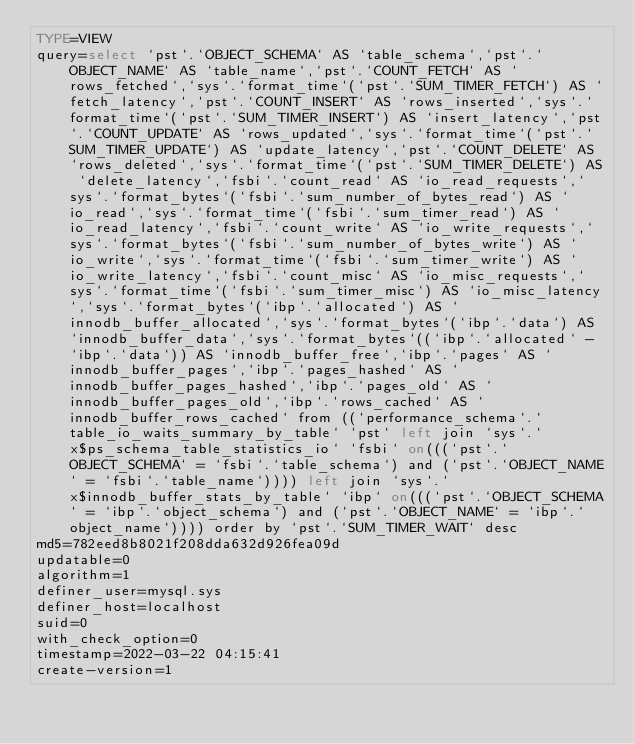<code> <loc_0><loc_0><loc_500><loc_500><_VisualBasic_>TYPE=VIEW
query=select `pst`.`OBJECT_SCHEMA` AS `table_schema`,`pst`.`OBJECT_NAME` AS `table_name`,`pst`.`COUNT_FETCH` AS `rows_fetched`,`sys`.`format_time`(`pst`.`SUM_TIMER_FETCH`) AS `fetch_latency`,`pst`.`COUNT_INSERT` AS `rows_inserted`,`sys`.`format_time`(`pst`.`SUM_TIMER_INSERT`) AS `insert_latency`,`pst`.`COUNT_UPDATE` AS `rows_updated`,`sys`.`format_time`(`pst`.`SUM_TIMER_UPDATE`) AS `update_latency`,`pst`.`COUNT_DELETE` AS `rows_deleted`,`sys`.`format_time`(`pst`.`SUM_TIMER_DELETE`) AS `delete_latency`,`fsbi`.`count_read` AS `io_read_requests`,`sys`.`format_bytes`(`fsbi`.`sum_number_of_bytes_read`) AS `io_read`,`sys`.`format_time`(`fsbi`.`sum_timer_read`) AS `io_read_latency`,`fsbi`.`count_write` AS `io_write_requests`,`sys`.`format_bytes`(`fsbi`.`sum_number_of_bytes_write`) AS `io_write`,`sys`.`format_time`(`fsbi`.`sum_timer_write`) AS `io_write_latency`,`fsbi`.`count_misc` AS `io_misc_requests`,`sys`.`format_time`(`fsbi`.`sum_timer_misc`) AS `io_misc_latency`,`sys`.`format_bytes`(`ibp`.`allocated`) AS `innodb_buffer_allocated`,`sys`.`format_bytes`(`ibp`.`data`) AS `innodb_buffer_data`,`sys`.`format_bytes`((`ibp`.`allocated` - `ibp`.`data`)) AS `innodb_buffer_free`,`ibp`.`pages` AS `innodb_buffer_pages`,`ibp`.`pages_hashed` AS `innodb_buffer_pages_hashed`,`ibp`.`pages_old` AS `innodb_buffer_pages_old`,`ibp`.`rows_cached` AS `innodb_buffer_rows_cached` from ((`performance_schema`.`table_io_waits_summary_by_table` `pst` left join `sys`.`x$ps_schema_table_statistics_io` `fsbi` on(((`pst`.`OBJECT_SCHEMA` = `fsbi`.`table_schema`) and (`pst`.`OBJECT_NAME` = `fsbi`.`table_name`)))) left join `sys`.`x$innodb_buffer_stats_by_table` `ibp` on(((`pst`.`OBJECT_SCHEMA` = `ibp`.`object_schema`) and (`pst`.`OBJECT_NAME` = `ibp`.`object_name`)))) order by `pst`.`SUM_TIMER_WAIT` desc
md5=782eed8b8021f208dda632d926fea09d
updatable=0
algorithm=1
definer_user=mysql.sys
definer_host=localhost
suid=0
with_check_option=0
timestamp=2022-03-22 04:15:41
create-version=1</code> 